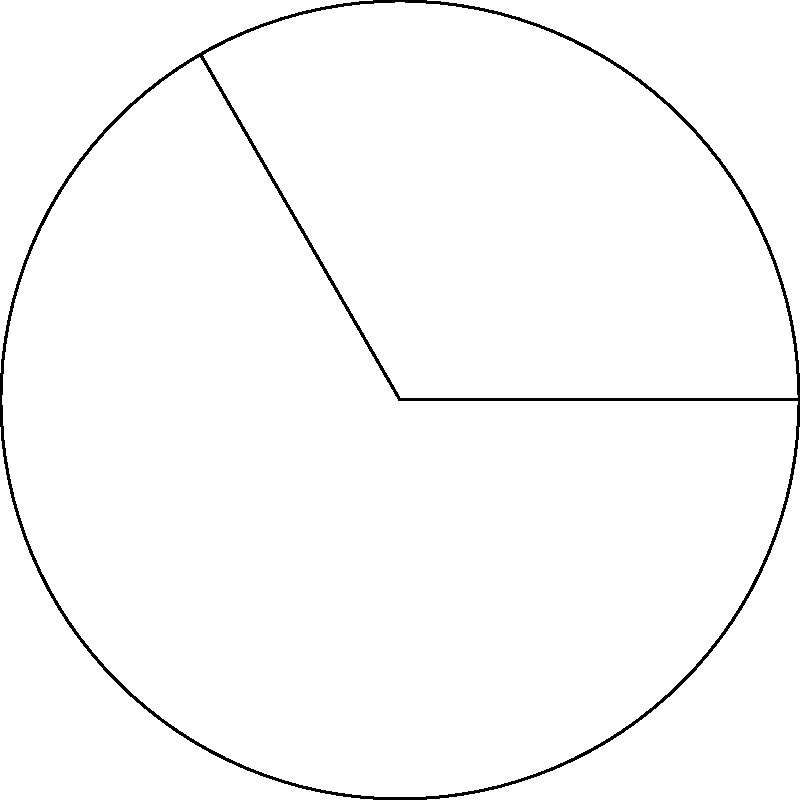In a garden filled with fragrant roses, a petal's curve catches your eye, reminding you of a perfect circle segment. This arc spans 120° of a circle with radius 3 cm. Calculate the length of this arc, which could inspire the description of a delicate flower petal in your next romance novel. To find the arc length, we'll follow these steps:

1) The formula for arc length is:
   $$s = r\theta$$
   where $s$ is the arc length, $r$ is the radius, and $\theta$ is the central angle in radians.

2) We're given the angle in degrees (120°), so we need to convert it to radians:
   $$\theta = 120° \times \frac{\pi}{180°} = \frac{2\pi}{3} \text{ radians}$$

3) Now we can substitute the values into our formula:
   $$s = r\theta = 3 \times \frac{2\pi}{3}$$

4) Simplify:
   $$s = 2\pi \text{ cm}$$

5) If we want to calculate the exact value:
   $$s = 2\pi \approx 6.28 \text{ cm}$$

The arc length, representing the curve of your inspiring petal, is $2\pi$ cm or approximately 6.28 cm.
Answer: $2\pi$ cm 